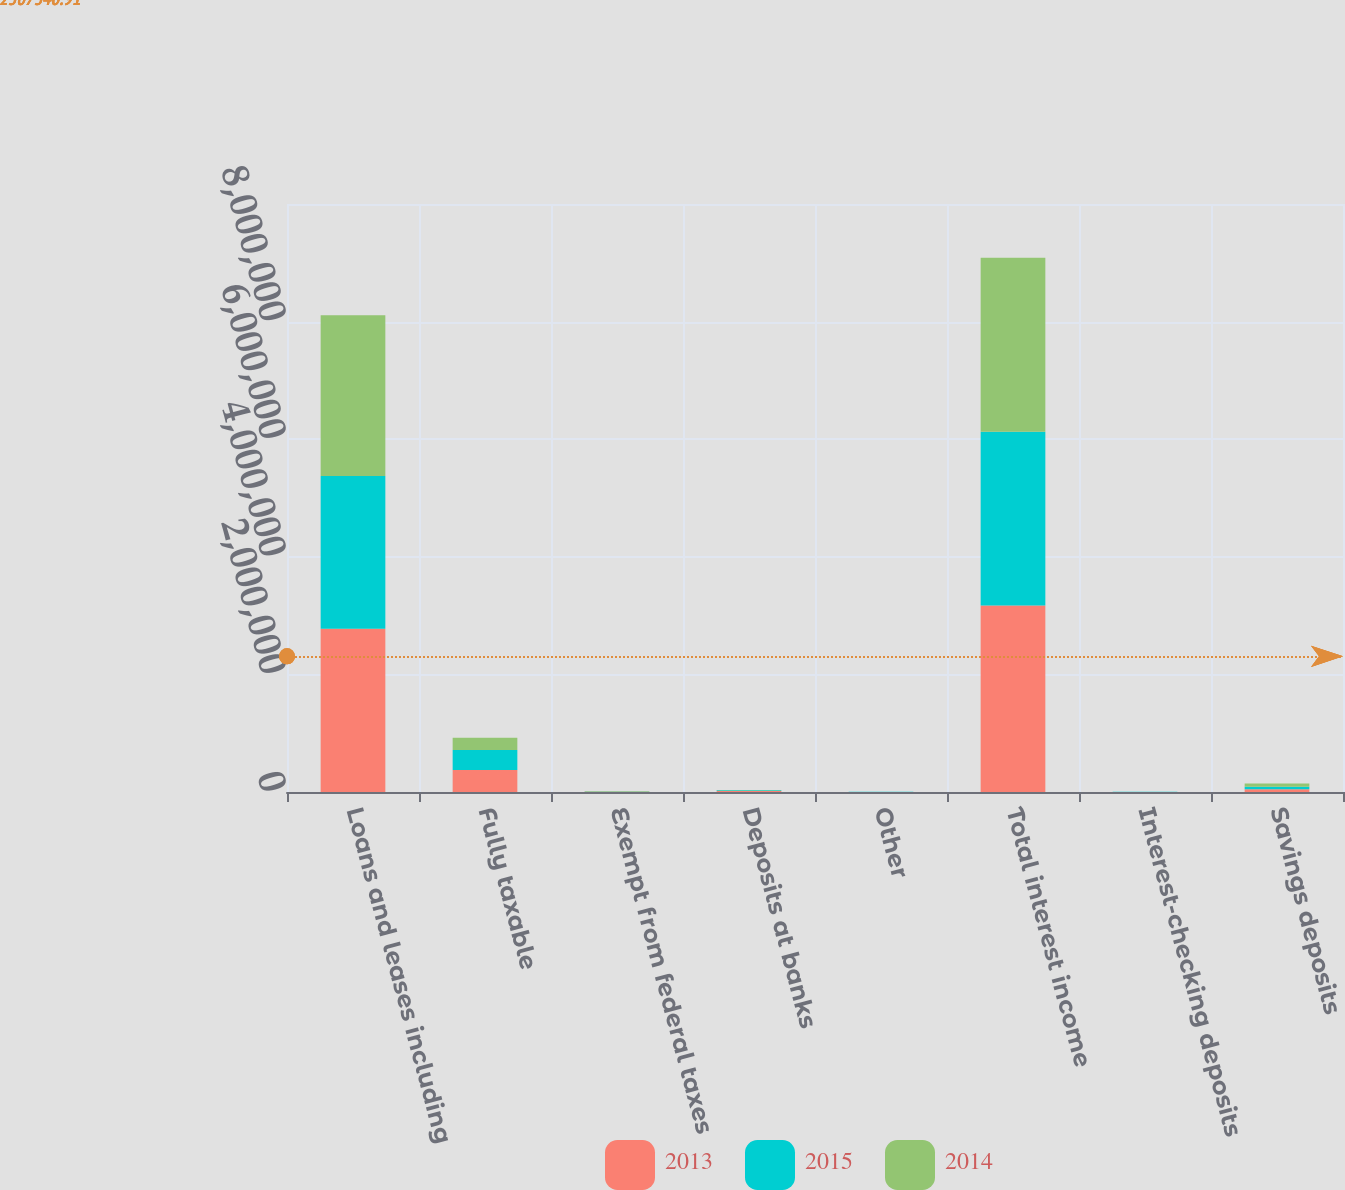<chart> <loc_0><loc_0><loc_500><loc_500><stacked_bar_chart><ecel><fcel>Loans and leases including<fcel>Fully taxable<fcel>Exempt from federal taxes<fcel>Deposits at banks<fcel>Other<fcel>Total interest income<fcel>Interest-checking deposits<fcel>Savings deposits<nl><fcel>2013<fcel>2.77815e+06<fcel>372162<fcel>4263<fcel>15252<fcel>1016<fcel>3.17084e+06<fcel>1404<fcel>44736<nl><fcel>2015<fcel>2.59659e+06<fcel>340391<fcel>5356<fcel>13361<fcel>1183<fcel>2.95688e+06<fcel>1404<fcel>45465<nl><fcel>2014<fcel>2.73471e+06<fcel>209244<fcel>6802<fcel>5201<fcel>1379<fcel>2.95733e+06<fcel>1287<fcel>54948<nl></chart> 